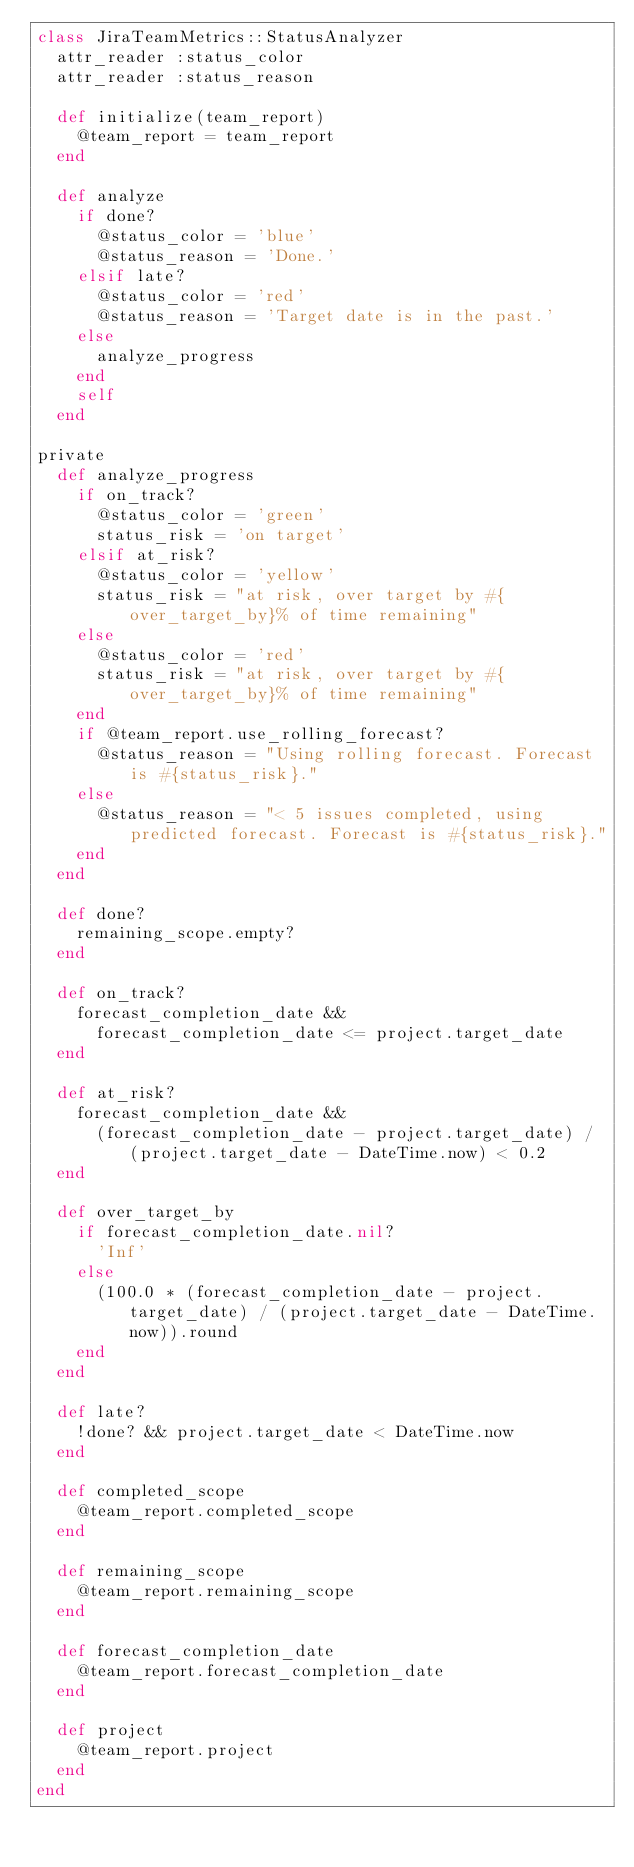<code> <loc_0><loc_0><loc_500><loc_500><_Ruby_>class JiraTeamMetrics::StatusAnalyzer
  attr_reader :status_color
  attr_reader :status_reason

  def initialize(team_report)
    @team_report = team_report
  end

  def analyze
    if done?
      @status_color = 'blue'
      @status_reason = 'Done.'
    elsif late?
      @status_color = 'red'
      @status_reason = 'Target date is in the past.'
    else
      analyze_progress
    end
    self
  end

private
  def analyze_progress
    if on_track?
      @status_color = 'green'
      status_risk = 'on target'
    elsif at_risk?
      @status_color = 'yellow'
      status_risk = "at risk, over target by #{over_target_by}% of time remaining"
    else
      @status_color = 'red'
      status_risk = "at risk, over target by #{over_target_by}% of time remaining"
    end
    if @team_report.use_rolling_forecast?
      @status_reason = "Using rolling forecast. Forecast is #{status_risk}."
    else
      @status_reason = "< 5 issues completed, using predicted forecast. Forecast is #{status_risk}."
    end
  end

  def done?
    remaining_scope.empty?
  end

  def on_track?
    forecast_completion_date &&
      forecast_completion_date <= project.target_date
  end

  def at_risk?
    forecast_completion_date &&
      (forecast_completion_date - project.target_date) / (project.target_date - DateTime.now) < 0.2
  end

  def over_target_by
    if forecast_completion_date.nil?
      'Inf'
    else
      (100.0 * (forecast_completion_date - project.target_date) / (project.target_date - DateTime.now)).round
    end
  end

  def late?
    !done? && project.target_date < DateTime.now
  end

  def completed_scope
    @team_report.completed_scope
  end

  def remaining_scope
    @team_report.remaining_scope
  end

  def forecast_completion_date
    @team_report.forecast_completion_date
  end

  def project
    @team_report.project
  end
end
</code> 